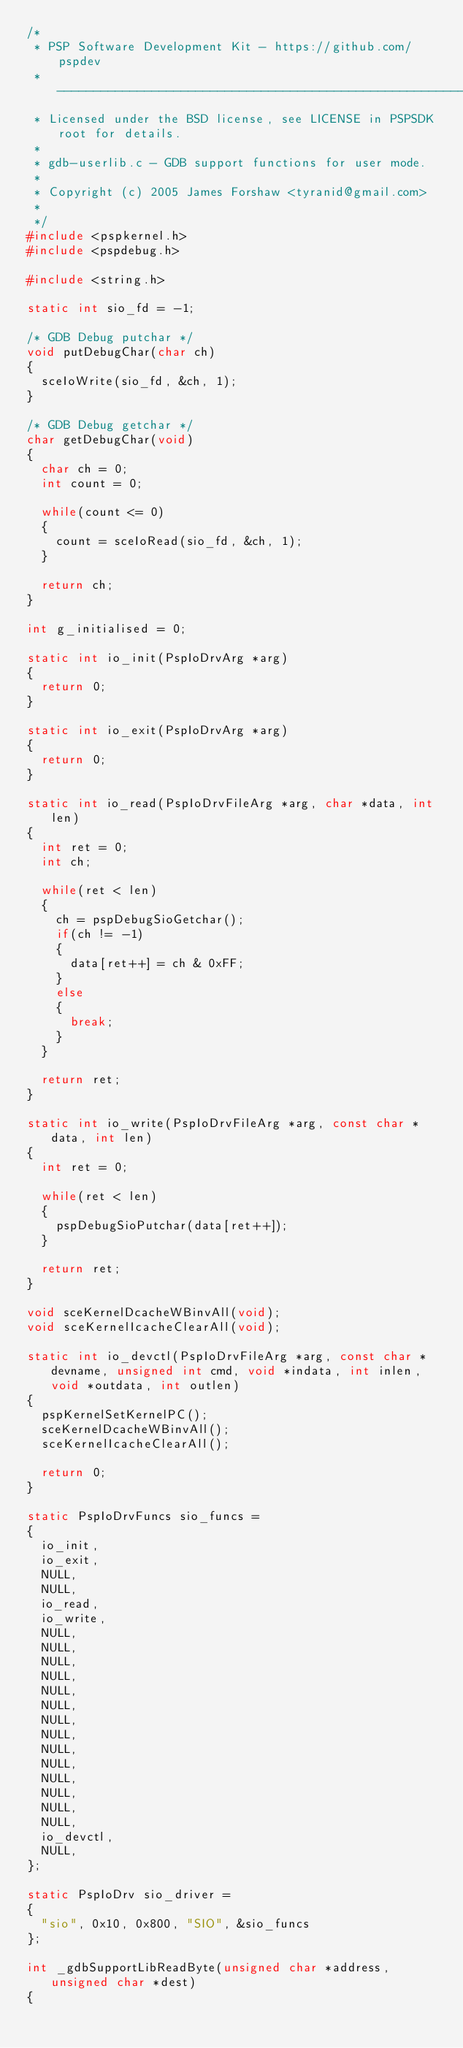<code> <loc_0><loc_0><loc_500><loc_500><_C_>/*
 * PSP Software Development Kit - https://github.com/pspdev
 * -----------------------------------------------------------------------
 * Licensed under the BSD license, see LICENSE in PSPSDK root for details.
 *
 * gdb-userlib.c - GDB support functions for user mode.
 *
 * Copyright (c) 2005 James Forshaw <tyranid@gmail.com>
 *
 */
#include <pspkernel.h>
#include <pspdebug.h>

#include <string.h>

static int sio_fd = -1;

/* GDB Debug putchar */
void putDebugChar(char ch)
{
	sceIoWrite(sio_fd, &ch, 1);
}

/* GDB Debug getchar */
char getDebugChar(void)
{
	char ch = 0;
	int count = 0;

	while(count <= 0)
	{
		count = sceIoRead(sio_fd, &ch, 1);
	}

	return ch;
}

int g_initialised = 0;

static int io_init(PspIoDrvArg *arg)
{
	return 0;
}

static int io_exit(PspIoDrvArg *arg)
{
	return 0;
}

static int io_read(PspIoDrvFileArg *arg, char *data, int len)
{
	int ret = 0;
	int ch;

	while(ret < len)
	{
		ch = pspDebugSioGetchar();
		if(ch != -1)
		{
			data[ret++] = ch & 0xFF;
		}
		else
		{
			break;
		}
	}

	return ret;
}

static int io_write(PspIoDrvFileArg *arg, const char *data, int len)
{
	int ret = 0;

	while(ret < len)
	{
		pspDebugSioPutchar(data[ret++]);
	}

	return ret;
}

void sceKernelDcacheWBinvAll(void);
void sceKernelIcacheClearAll(void);

static int io_devctl(PspIoDrvFileArg *arg, const char *devname, unsigned int cmd, void *indata, int inlen, void *outdata, int outlen)
{
	pspKernelSetKernelPC();
	sceKernelDcacheWBinvAll();
	sceKernelIcacheClearAll();

	return 0;
}

static PspIoDrvFuncs sio_funcs = 
{
	io_init,
	io_exit,
	NULL,
	NULL,
	io_read,
	io_write,
	NULL,
	NULL,
	NULL,
	NULL,
	NULL,
	NULL,
	NULL,
	NULL,
	NULL,
	NULL,
	NULL,
	NULL,
	NULL,
	NULL,
	io_devctl,
	NULL,
};

static PspIoDrv sio_driver = 
{
	"sio", 0x10, 0x800, "SIO", &sio_funcs
};

int _gdbSupportLibReadByte(unsigned char *address, unsigned char *dest)
{</code> 